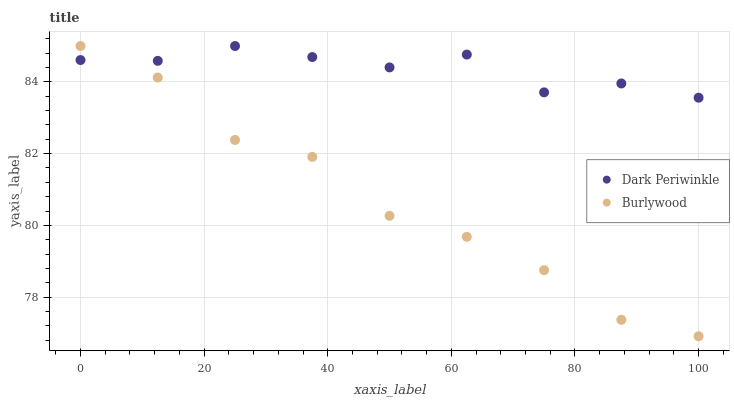Does Burlywood have the minimum area under the curve?
Answer yes or no. Yes. Does Dark Periwinkle have the maximum area under the curve?
Answer yes or no. Yes. Does Dark Periwinkle have the minimum area under the curve?
Answer yes or no. No. Is Dark Periwinkle the smoothest?
Answer yes or no. Yes. Is Burlywood the roughest?
Answer yes or no. Yes. Is Dark Periwinkle the roughest?
Answer yes or no. No. Does Burlywood have the lowest value?
Answer yes or no. Yes. Does Dark Periwinkle have the lowest value?
Answer yes or no. No. Does Dark Periwinkle have the highest value?
Answer yes or no. Yes. Does Burlywood intersect Dark Periwinkle?
Answer yes or no. Yes. Is Burlywood less than Dark Periwinkle?
Answer yes or no. No. Is Burlywood greater than Dark Periwinkle?
Answer yes or no. No. 